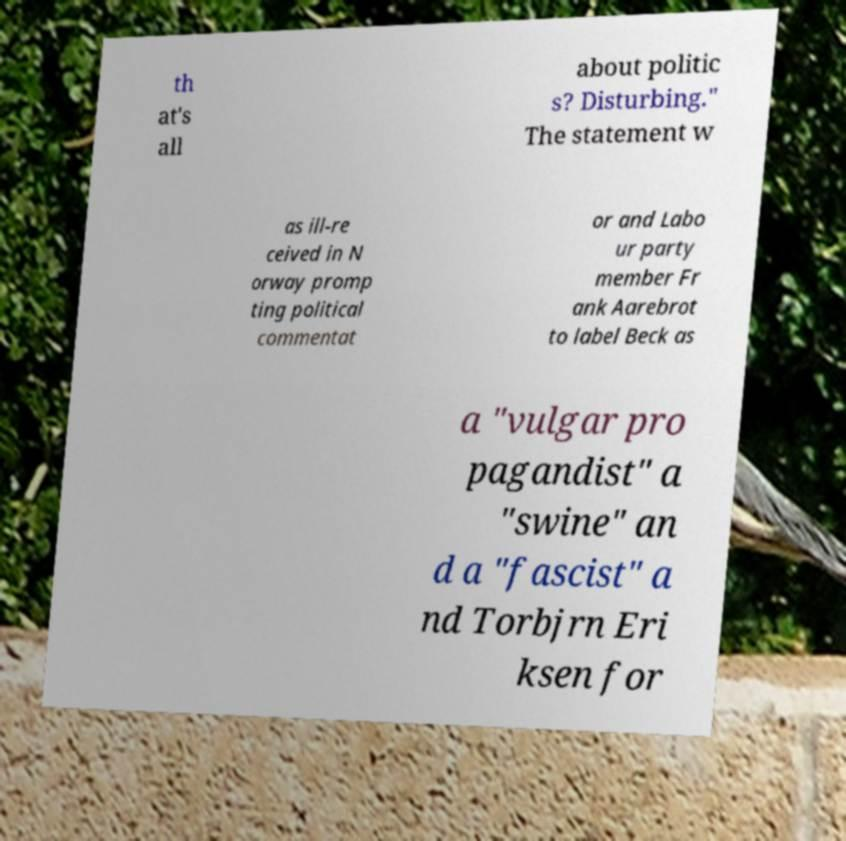For documentation purposes, I need the text within this image transcribed. Could you provide that? th at's all about politic s? Disturbing." The statement w as ill-re ceived in N orway promp ting political commentat or and Labo ur party member Fr ank Aarebrot to label Beck as a "vulgar pro pagandist" a "swine" an d a "fascist" a nd Torbjrn Eri ksen for 